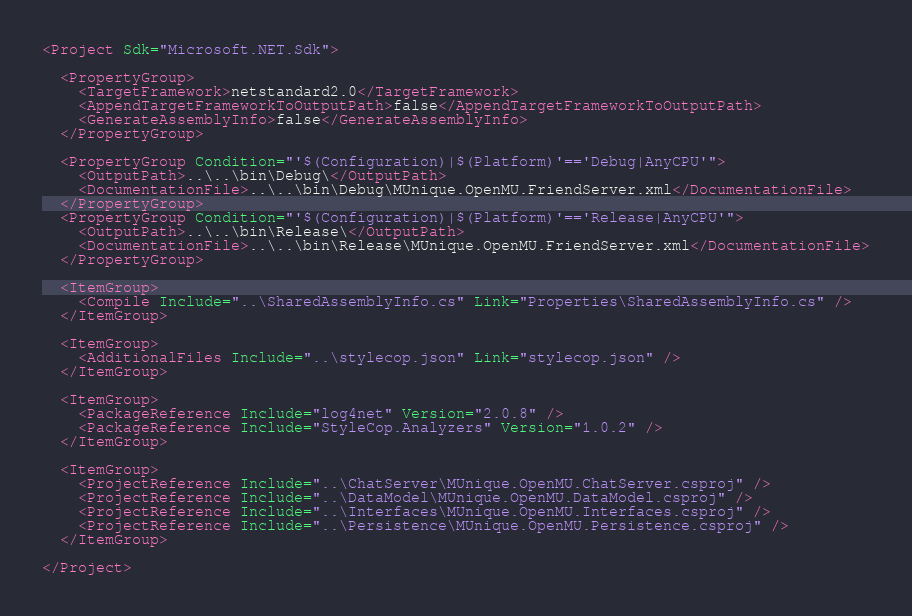Convert code to text. <code><loc_0><loc_0><loc_500><loc_500><_XML_><Project Sdk="Microsoft.NET.Sdk">

  <PropertyGroup>
    <TargetFramework>netstandard2.0</TargetFramework>
    <AppendTargetFrameworkToOutputPath>false</AppendTargetFrameworkToOutputPath>
    <GenerateAssemblyInfo>false</GenerateAssemblyInfo>
  </PropertyGroup>

  <PropertyGroup Condition="'$(Configuration)|$(Platform)'=='Debug|AnyCPU'">
    <OutputPath>..\..\bin\Debug\</OutputPath>
    <DocumentationFile>..\..\bin\Debug\MUnique.OpenMU.FriendServer.xml</DocumentationFile>
  </PropertyGroup>
  <PropertyGroup Condition="'$(Configuration)|$(Platform)'=='Release|AnyCPU'">
    <OutputPath>..\..\bin\Release\</OutputPath>
	<DocumentationFile>..\..\bin\Release\MUnique.OpenMU.FriendServer.xml</DocumentationFile>
  </PropertyGroup>

  <ItemGroup>
    <Compile Include="..\SharedAssemblyInfo.cs" Link="Properties\SharedAssemblyInfo.cs" />
  </ItemGroup>

  <ItemGroup>
    <AdditionalFiles Include="..\stylecop.json" Link="stylecop.json" />
  </ItemGroup>

  <ItemGroup>
    <PackageReference Include="log4net" Version="2.0.8" />
    <PackageReference Include="StyleCop.Analyzers" Version="1.0.2" />
  </ItemGroup>

  <ItemGroup>
    <ProjectReference Include="..\ChatServer\MUnique.OpenMU.ChatServer.csproj" />
    <ProjectReference Include="..\DataModel\MUnique.OpenMU.DataModel.csproj" />
    <ProjectReference Include="..\Interfaces\MUnique.OpenMU.Interfaces.csproj" />
    <ProjectReference Include="..\Persistence\MUnique.OpenMU.Persistence.csproj" />
  </ItemGroup>

</Project>
</code> 